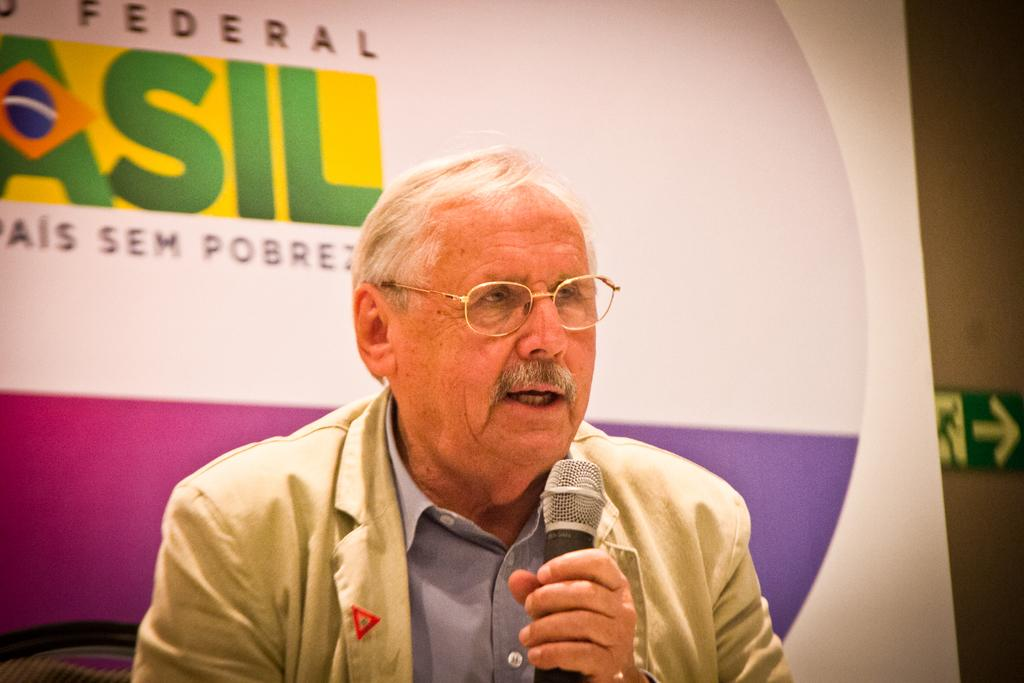What is the person in the image doing? The person is speaking in the image. What is the person holding while speaking? The person is holding a microphone in his hand. What can be seen in the background of the image? There is a banner in the image. What word is written on the banner? The word "federal" is written on the banner. What type of guitar is the person playing in the image? There is no guitar present in the image; the person is holding a microphone and speaking. What liquid can be seen spilling from the banner in the image? There is no liquid present in the image, and the banner is not depicted as spilling anything. 